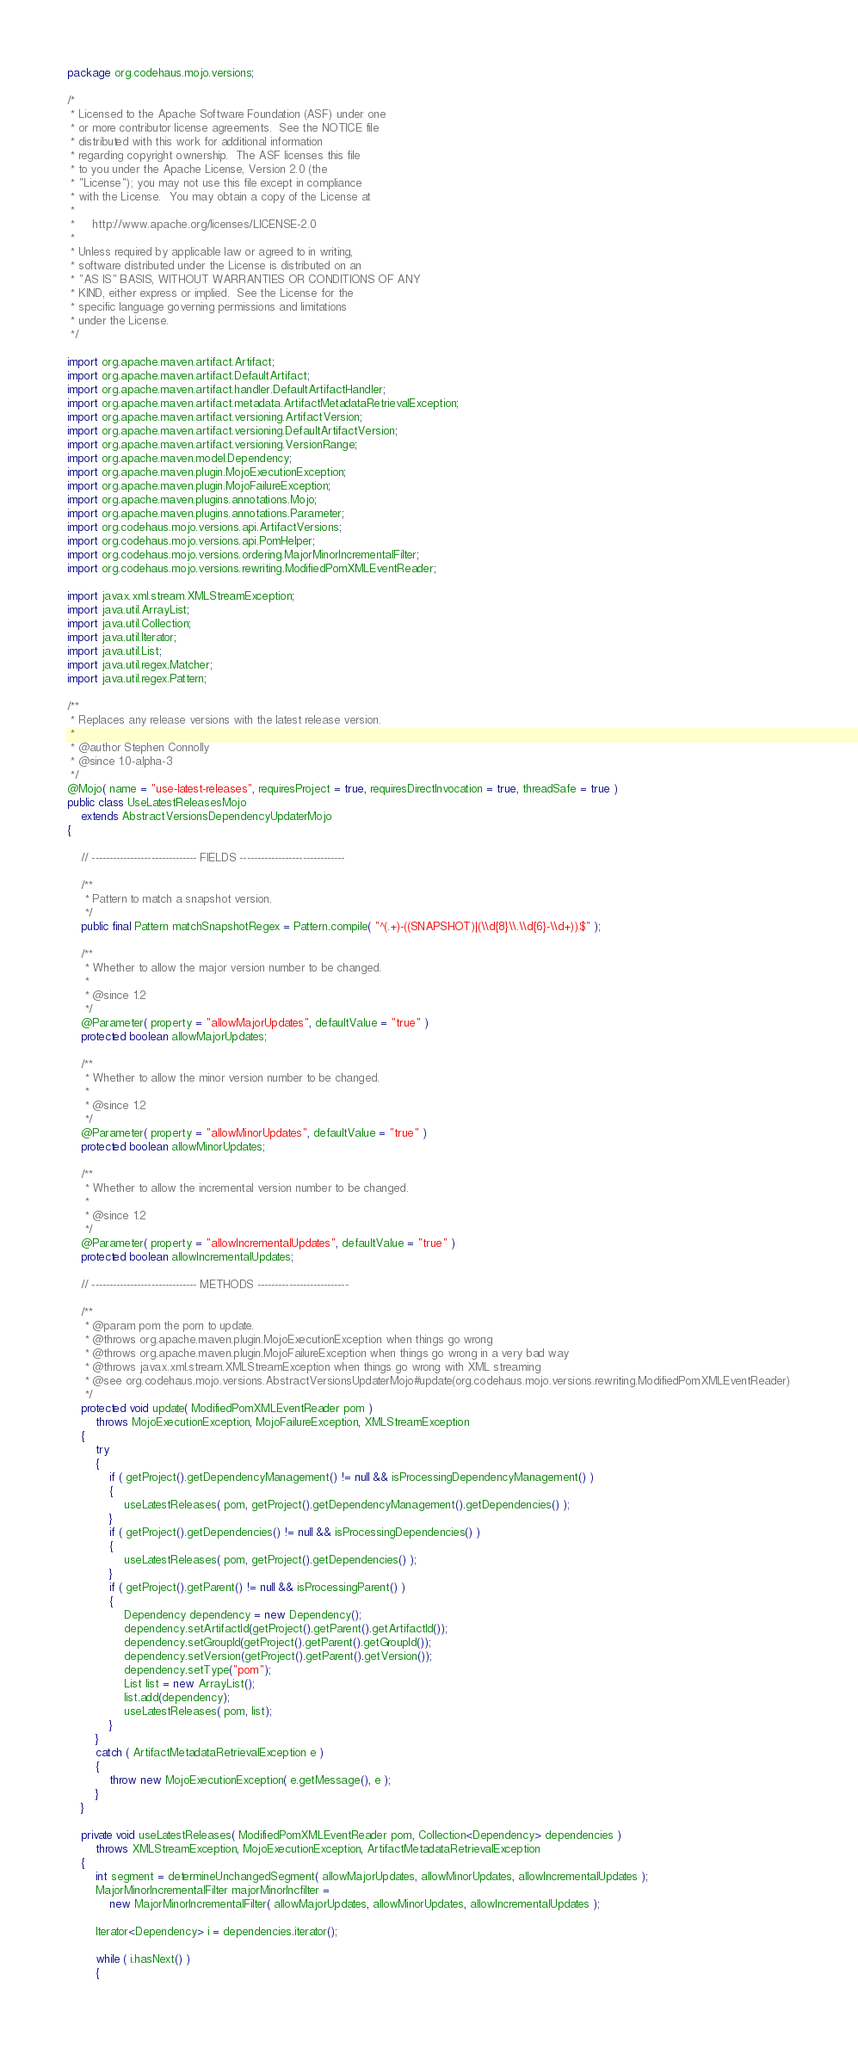Convert code to text. <code><loc_0><loc_0><loc_500><loc_500><_Java_>package org.codehaus.mojo.versions;

/*
 * Licensed to the Apache Software Foundation (ASF) under one
 * or more contributor license agreements.  See the NOTICE file
 * distributed with this work for additional information
 * regarding copyright ownership.  The ASF licenses this file
 * to you under the Apache License, Version 2.0 (the
 * "License"); you may not use this file except in compliance
 * with the License.  You may obtain a copy of the License at
 *
 *     http://www.apache.org/licenses/LICENSE-2.0
 *
 * Unless required by applicable law or agreed to in writing,
 * software distributed under the License is distributed on an
 * "AS IS" BASIS, WITHOUT WARRANTIES OR CONDITIONS OF ANY
 * KIND, either express or implied.  See the License for the
 * specific language governing permissions and limitations
 * under the License.
 */

import org.apache.maven.artifact.Artifact;
import org.apache.maven.artifact.DefaultArtifact;
import org.apache.maven.artifact.handler.DefaultArtifactHandler;
import org.apache.maven.artifact.metadata.ArtifactMetadataRetrievalException;
import org.apache.maven.artifact.versioning.ArtifactVersion;
import org.apache.maven.artifact.versioning.DefaultArtifactVersion;
import org.apache.maven.artifact.versioning.VersionRange;
import org.apache.maven.model.Dependency;
import org.apache.maven.plugin.MojoExecutionException;
import org.apache.maven.plugin.MojoFailureException;
import org.apache.maven.plugins.annotations.Mojo;
import org.apache.maven.plugins.annotations.Parameter;
import org.codehaus.mojo.versions.api.ArtifactVersions;
import org.codehaus.mojo.versions.api.PomHelper;
import org.codehaus.mojo.versions.ordering.MajorMinorIncrementalFilter;
import org.codehaus.mojo.versions.rewriting.ModifiedPomXMLEventReader;

import javax.xml.stream.XMLStreamException;
import java.util.ArrayList;
import java.util.Collection;
import java.util.Iterator;
import java.util.List;
import java.util.regex.Matcher;
import java.util.regex.Pattern;

/**
 * Replaces any release versions with the latest release version.
 *
 * @author Stephen Connolly
 * @since 1.0-alpha-3
 */
@Mojo( name = "use-latest-releases", requiresProject = true, requiresDirectInvocation = true, threadSafe = true )
public class UseLatestReleasesMojo
    extends AbstractVersionsDependencyUpdaterMojo
{

    // ------------------------------ FIELDS ------------------------------

    /**
     * Pattern to match a snapshot version.
     */
    public final Pattern matchSnapshotRegex = Pattern.compile( "^(.+)-((SNAPSHOT)|(\\d{8}\\.\\d{6}-\\d+))$" );

    /**
     * Whether to allow the major version number to be changed.
     *
     * @since 1.2
     */
    @Parameter( property = "allowMajorUpdates", defaultValue = "true" )
    protected boolean allowMajorUpdates;

    /**
     * Whether to allow the minor version number to be changed.
     *
     * @since 1.2
     */
    @Parameter( property = "allowMinorUpdates", defaultValue = "true" )
    protected boolean allowMinorUpdates;

    /**
     * Whether to allow the incremental version number to be changed.
     *
     * @since 1.2
     */
    @Parameter( property = "allowIncrementalUpdates", defaultValue = "true" )
    protected boolean allowIncrementalUpdates;

    // ------------------------------ METHODS --------------------------

    /**
     * @param pom the pom to update.
     * @throws org.apache.maven.plugin.MojoExecutionException when things go wrong
     * @throws org.apache.maven.plugin.MojoFailureException when things go wrong in a very bad way
     * @throws javax.xml.stream.XMLStreamException when things go wrong with XML streaming
     * @see org.codehaus.mojo.versions.AbstractVersionsUpdaterMojo#update(org.codehaus.mojo.versions.rewriting.ModifiedPomXMLEventReader)
     */
    protected void update( ModifiedPomXMLEventReader pom )
        throws MojoExecutionException, MojoFailureException, XMLStreamException
    {
        try
        {
            if ( getProject().getDependencyManagement() != null && isProcessingDependencyManagement() )
            {
                useLatestReleases( pom, getProject().getDependencyManagement().getDependencies() );
            }
            if ( getProject().getDependencies() != null && isProcessingDependencies() )
            {
                useLatestReleases( pom, getProject().getDependencies() );
            }
            if ( getProject().getParent() != null && isProcessingParent() )
            {
                Dependency dependency = new Dependency();
                dependency.setArtifactId(getProject().getParent().getArtifactId());
                dependency.setGroupId(getProject().getParent().getGroupId());
                dependency.setVersion(getProject().getParent().getVersion());
                dependency.setType("pom");
                List list = new ArrayList();
                list.add(dependency);
                useLatestReleases( pom, list);
            }
        }
        catch ( ArtifactMetadataRetrievalException e )
        {
            throw new MojoExecutionException( e.getMessage(), e );
        }
    }

    private void useLatestReleases( ModifiedPomXMLEventReader pom, Collection<Dependency> dependencies )
        throws XMLStreamException, MojoExecutionException, ArtifactMetadataRetrievalException
    {
        int segment = determineUnchangedSegment( allowMajorUpdates, allowMinorUpdates, allowIncrementalUpdates );
        MajorMinorIncrementalFilter majorMinorIncfilter =
            new MajorMinorIncrementalFilter( allowMajorUpdates, allowMinorUpdates, allowIncrementalUpdates );

        Iterator<Dependency> i = dependencies.iterator();

        while ( i.hasNext() )
        {</code> 